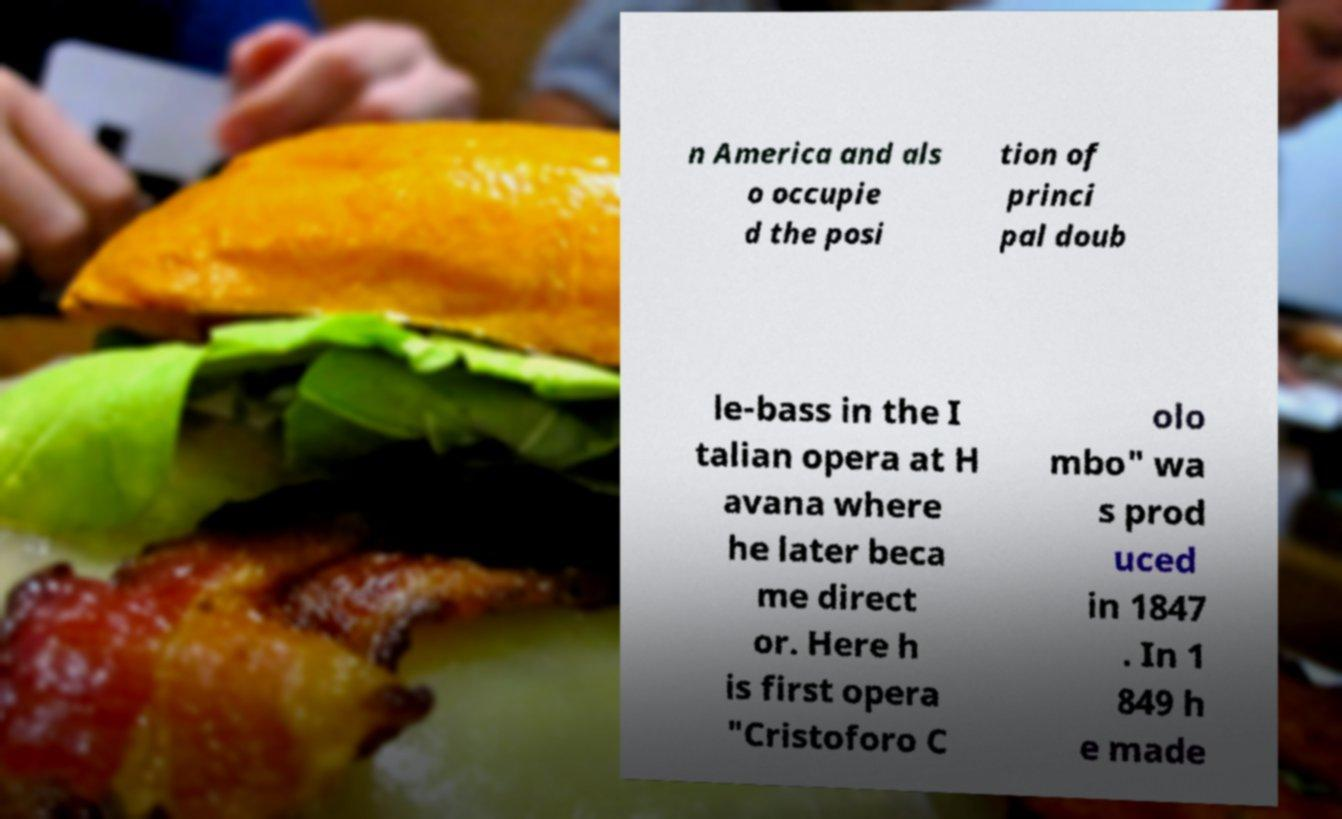Can you accurately transcribe the text from the provided image for me? n America and als o occupie d the posi tion of princi pal doub le-bass in the I talian opera at H avana where he later beca me direct or. Here h is first opera "Cristoforo C olo mbo" wa s prod uced in 1847 . In 1 849 h e made 